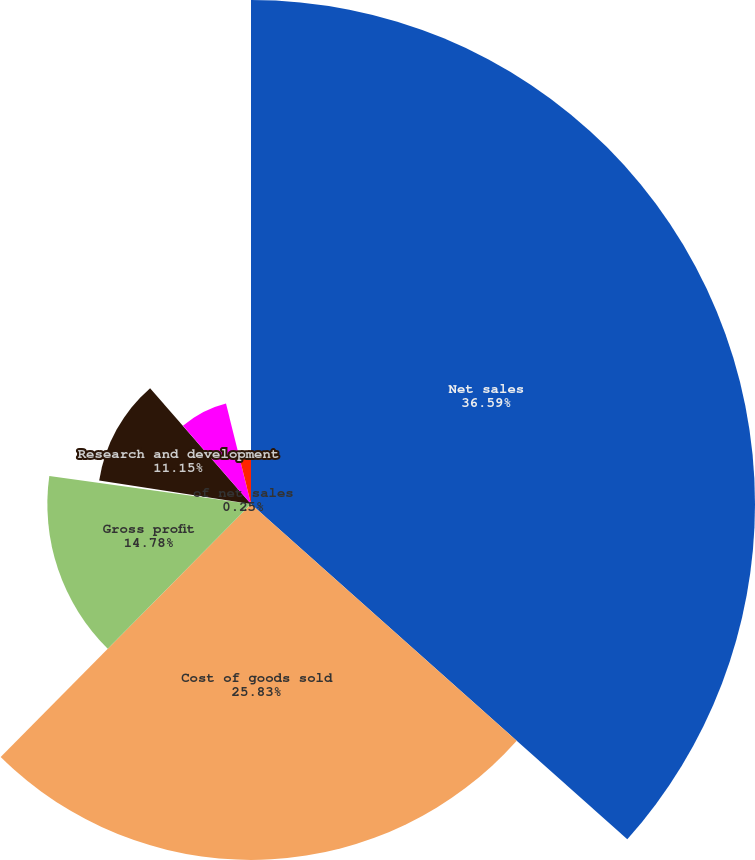Convert chart. <chart><loc_0><loc_0><loc_500><loc_500><pie_chart><fcel>Net sales<fcel>Cost of goods sold<fcel>Gross profit<fcel>of net sales<fcel>Research and development<fcel>Net interest expense<fcel>Effective tax rate<nl><fcel>36.58%<fcel>25.83%<fcel>14.78%<fcel>0.25%<fcel>11.15%<fcel>7.52%<fcel>3.88%<nl></chart> 